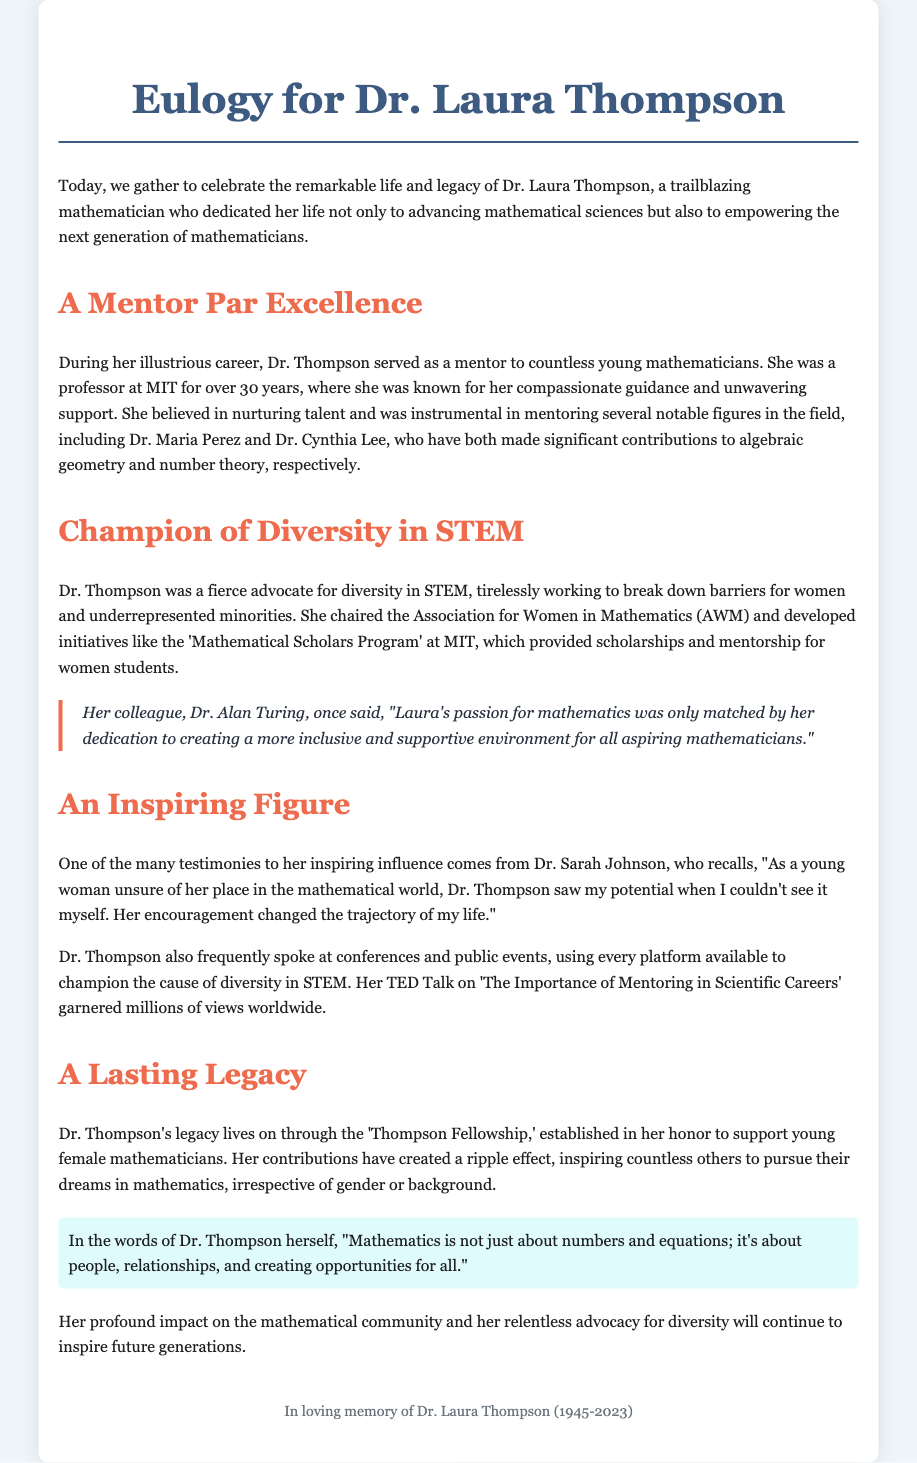What was Dr. Laura Thompson's profession? The document states that Dr. Thompson was a mathematician and a professor at MIT for over 30 years.
Answer: Mathematician What organization did Dr. Thompson chair? The text mentions that she chaired the Association for Women in Mathematics (AWM).
Answer: Association for Women in Mathematics Which program did Dr. Thompson develop at MIT? The document refers to the 'Mathematical Scholars Program' that she established to support women students.
Answer: Mathematical Scholars Program Who is one of the notable figures mentored by Dr. Thompson? The document lists Dr. Maria Perez as one of the individuals mentored by Dr. Thompson.
Answer: Dr. Maria Perez What did Dr. Thompson emphasize about mathematics in her own words? Dr. Thompson remarked that "Mathematics is not just about numbers and equations; it's about people, relationships, and creating opportunities for all."
Answer: Creating opportunities for all How long was Dr. Thompson a professor at MIT? The document specifies that she was a professor for over 30 years.
Answer: Over 30 years What type of talk did Dr. Thompson give that garnered millions of views? The eulogy mentions her TED Talk on 'The Importance of Mentoring in Scientific Careers'.
Answer: TED Talk What legacy was established in Dr. Thompson's honor? The text refers to the 'Thompson Fellowship' initiated to support young female mathematicians.
Answer: Thompson Fellowship 